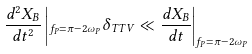<formula> <loc_0><loc_0><loc_500><loc_500>\frac { d ^ { 2 } X _ { B } } { d t ^ { 2 } } \left | _ { f _ { P } = \pi - 2 \omega _ { P } } \delta _ { T T V } \ll \frac { d X _ { B } } { d t } \right | _ { f _ { P } = \pi - 2 \omega _ { P } }</formula> 